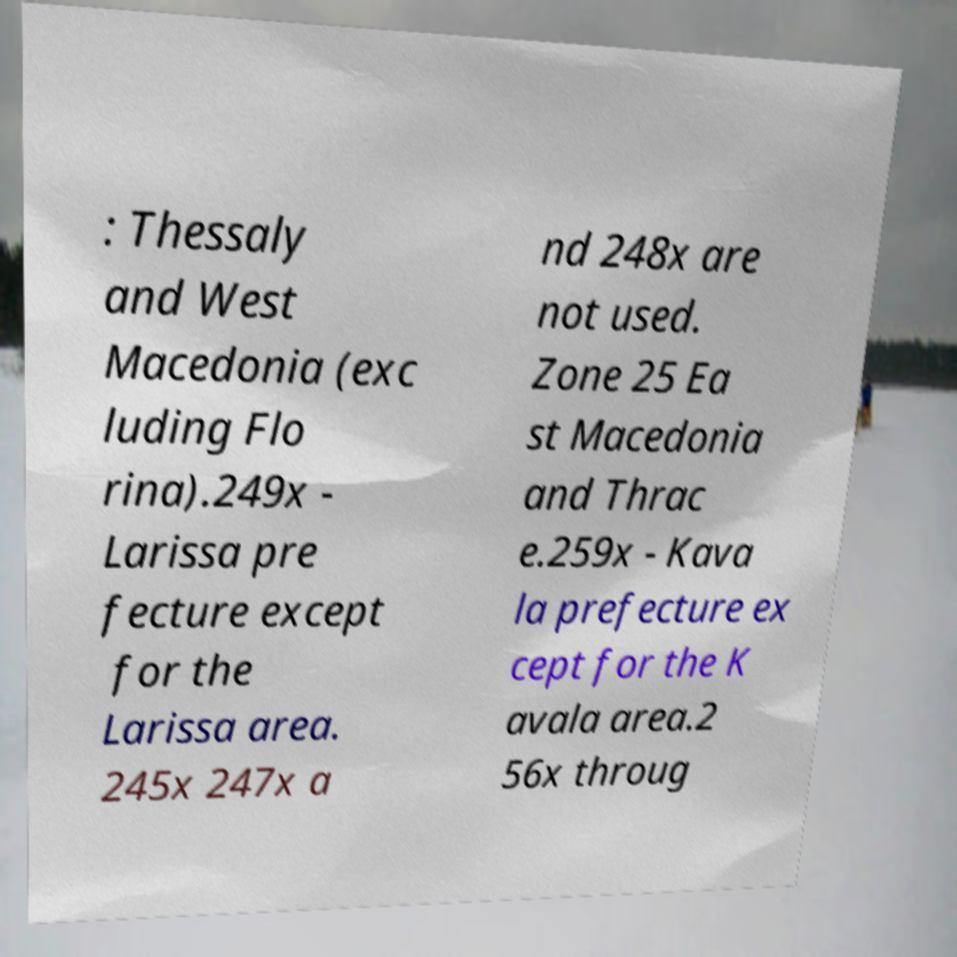There's text embedded in this image that I need extracted. Can you transcribe it verbatim? : Thessaly and West Macedonia (exc luding Flo rina).249x - Larissa pre fecture except for the Larissa area. 245x 247x a nd 248x are not used. Zone 25 Ea st Macedonia and Thrac e.259x - Kava la prefecture ex cept for the K avala area.2 56x throug 